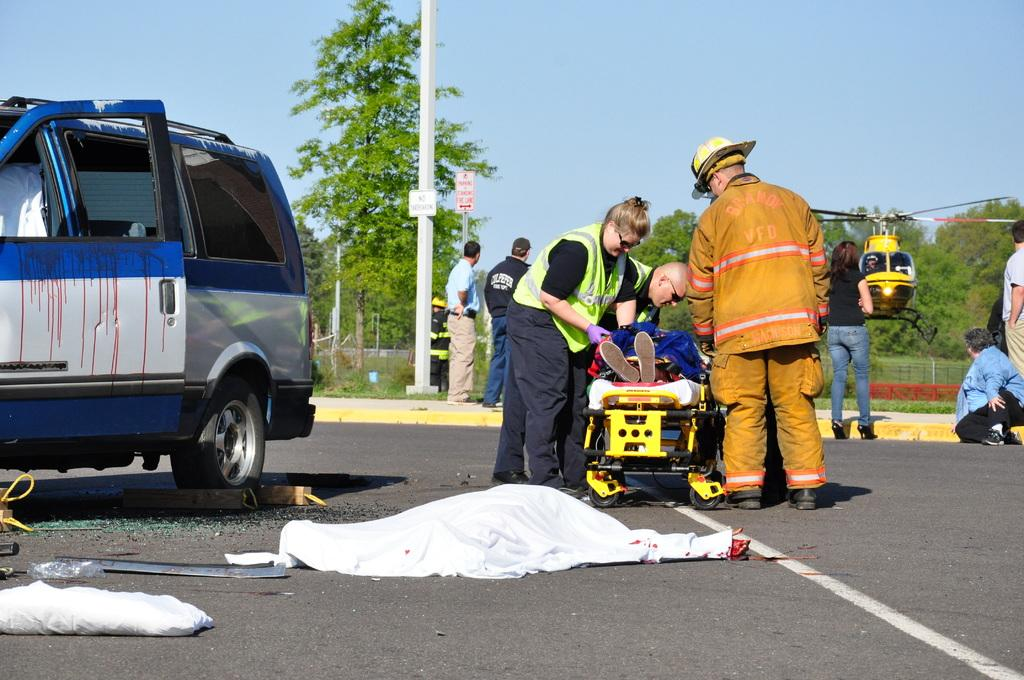What type of vehicle is in the image? There is a vehicle in the image, but the specific type is not mentioned. What is happening on the road in the image? There are people on the road in the image. What can be seen hanging or displayed in the image? Clothes, poles, and boards are visible in the image. What is flying in the sky in the image? There is a helicopter in the image. What type of objects are present in the image? There are objects in the image, but their specific nature is not mentioned. What can be seen in the background of the image? Trees and the sky are visible in the background of the image. What type of mist is covering the helicopter in the image? There is no mention of mist in the image; the helicopter is visible in the sky. What kind of bomb is being dropped from the helicopter in the image? There is no bomb present in the image; it only shows a helicopter in the sky. 